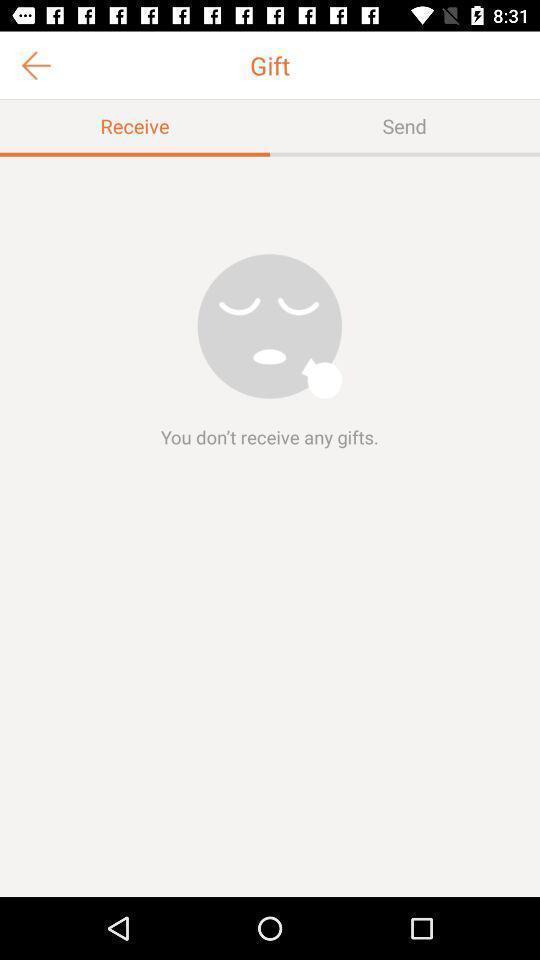Provide a textual representation of this image. Page showing gifts. 